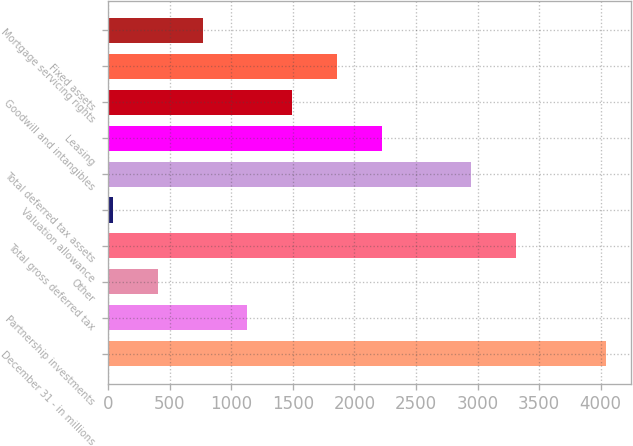Convert chart to OTSL. <chart><loc_0><loc_0><loc_500><loc_500><bar_chart><fcel>December 31 - in millions<fcel>Partnership investments<fcel>Other<fcel>Total gross deferred tax<fcel>Valuation allowance<fcel>Total deferred tax assets<fcel>Leasing<fcel>Goodwill and intangibles<fcel>Fixed assets<fcel>Mortgage servicing rights<nl><fcel>4040.7<fcel>1131.1<fcel>403.7<fcel>3313.3<fcel>40<fcel>2949.6<fcel>2222.2<fcel>1494.8<fcel>1858.5<fcel>767.4<nl></chart> 